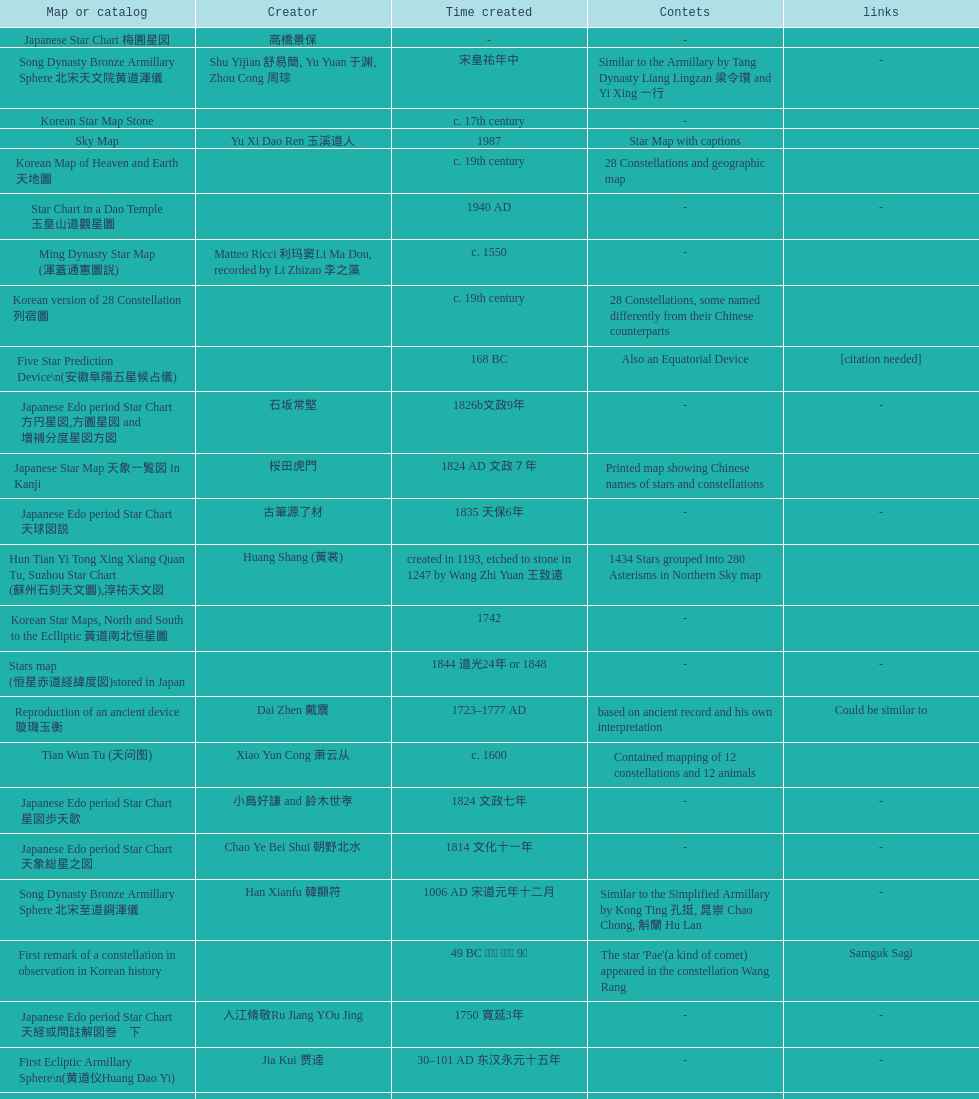When was the first map or catalog created? C. 4000 b.c. 